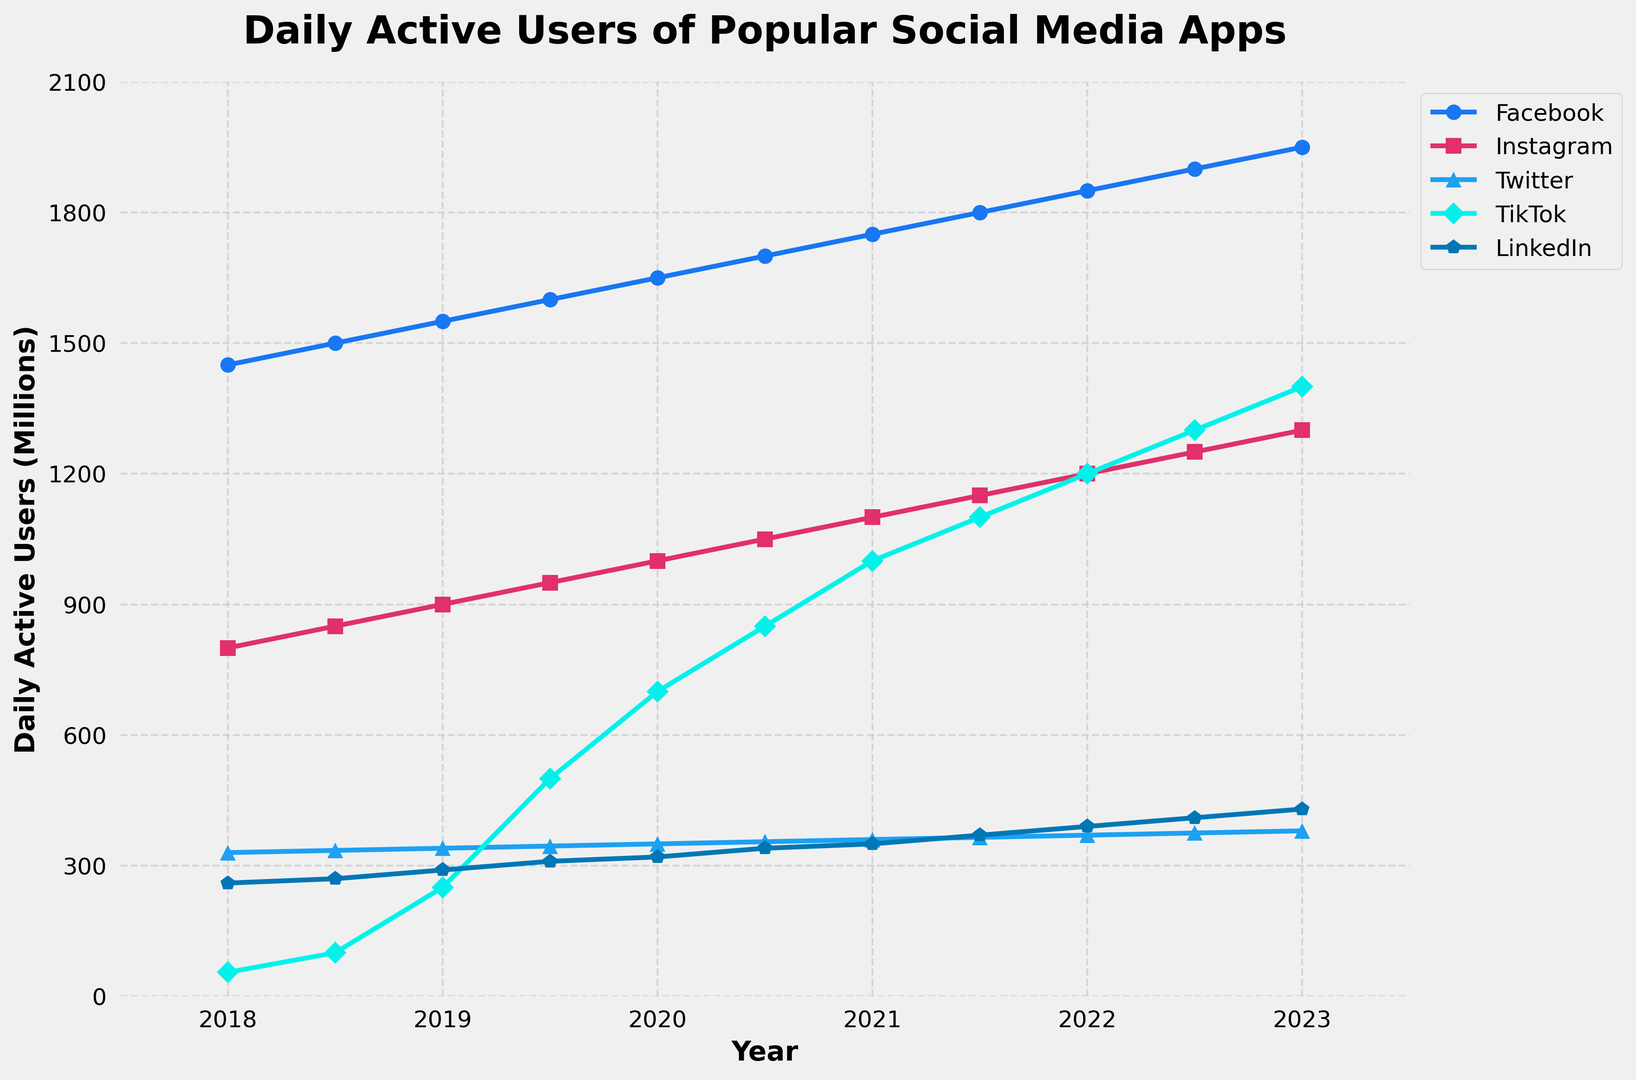What's the trend in the daily active users of Facebook over the five years? By looking at the line representing Facebook, we can observe that it consistently increases from 2018 to 2023. The trend shows a continuous upward trajectory without any declines.
Answer: Increasing Which app had the second highest number of daily active users in 2023? By examining the endpoints of the lines in 2023, TikTok reaches 1400, which is the second-highest right after Facebook.
Answer: TikTok How did Instagram's daily active users change from 2019 to 2021? In 2019, Instagram had 900 million users. In 2021, it had 1100 million users. Therefore, Instagram's daily active users increased by 200 million over these two years.
Answer: Increased by 200 million What is the difference in the number of daily active users between Twitter and LinkedIn in 2020? In 2020, Twitter had 350 million users, and LinkedIn had 320 million users. The difference is 350 - 320 = 30 million users.
Answer: 30 million Which social media app had the most significant growth in daily active users from 2018 to 2023? We can calculate the change for each app over the period. Facebook: 1950-1450 = 500, Instagram: 1300-800 = 500, Twitter: 380-330 = 50, TikTok: 1400-55 = 1345, LinkedIn: 430-260 = 170. TikTok had the largest growth of 1345 million users.
Answer: TikTok What is the total number of daily active users for the five apps combined in 2019? The combined number in 2019 is 1550 (Facebook) + 900 (Instagram) + 340 (Twitter) + 250 (TikTok) + 290 (LinkedIn) = 3330 million users.
Answer: 3330 million How many years did it take for TikTok to reach 1000 million daily active users? TikTok reached 1000 million daily active users in 2021, starting with 55 million in 2018. It took from the start of 2018 to 2021, which is 3 years.
Answer: 3 years Between which years did LinkedIn see the highest increase in daily active users? By comparing each year's change, the highest increase is from 2021 to 2022, with an increase from 370 to 390, which is a 20 million increase.
Answer: 2021 to 2022 What is the average number of TikTok daily active users from 2018 to 2023? The numbers from 2018 to 2023 are 55, 100, 250, 500, 700, 850, 1000, 1100, 1200, 1300, 1400. Summing these up: 9455, dividing by the number of data points (11) gives an average of 9455 / 11 = 860.45
Answer: 860.45 